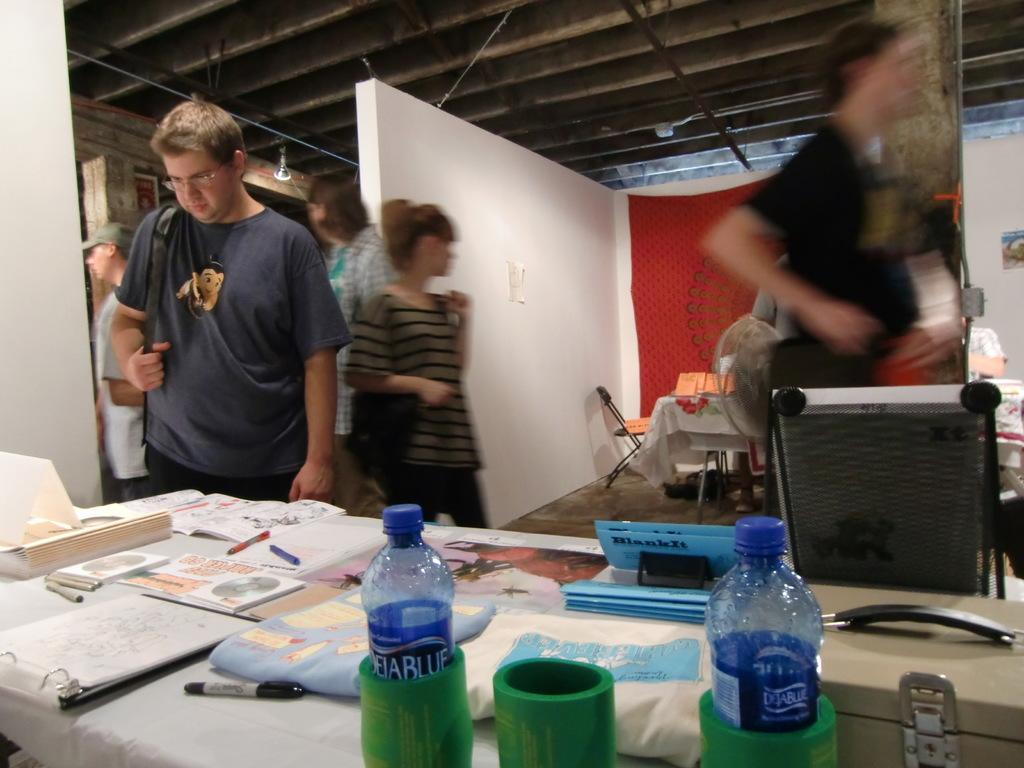<image>
Provide a brief description of the given image. People looking at a table with some DejaBlue water bottles on top. 